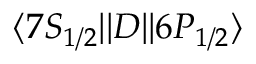Convert formula to latex. <formula><loc_0><loc_0><loc_500><loc_500>{ \langle 7 S _ { 1 / 2 } | | } D { | | 6 P _ { 1 / 2 } \rangle }</formula> 